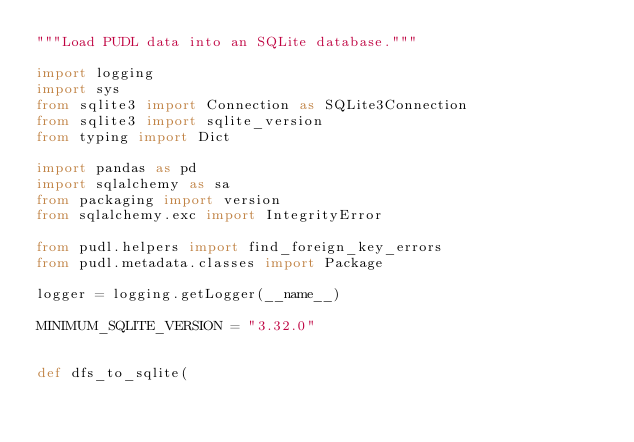Convert code to text. <code><loc_0><loc_0><loc_500><loc_500><_Python_>"""Load PUDL data into an SQLite database."""

import logging
import sys
from sqlite3 import Connection as SQLite3Connection
from sqlite3 import sqlite_version
from typing import Dict

import pandas as pd
import sqlalchemy as sa
from packaging import version
from sqlalchemy.exc import IntegrityError

from pudl.helpers import find_foreign_key_errors
from pudl.metadata.classes import Package

logger = logging.getLogger(__name__)

MINIMUM_SQLITE_VERSION = "3.32.0"


def dfs_to_sqlite(</code> 